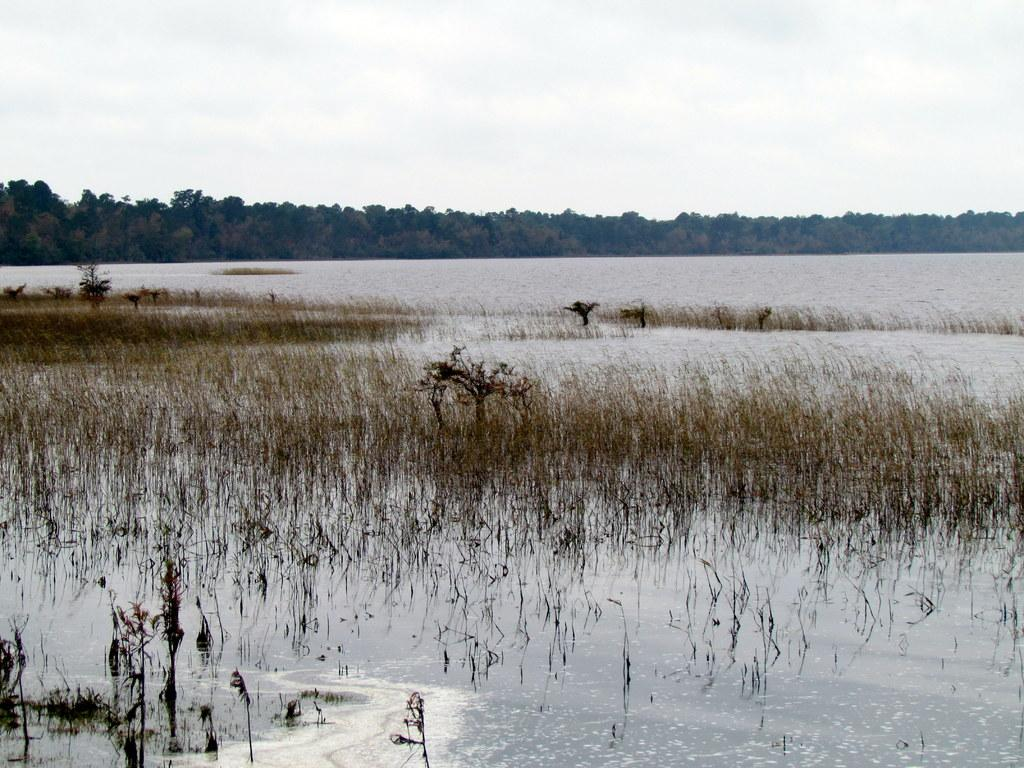What type of vegetation can be seen in the image? There is grass in the image. What else is present in the image besides grass? There is water and trees in the image. What can be seen in the background of the image? The sky is visible in the background of the image. What type of glue can be seen in the image? There is no glue present in the image. What type of soup is being served in the image? There is no soup present in the image. 